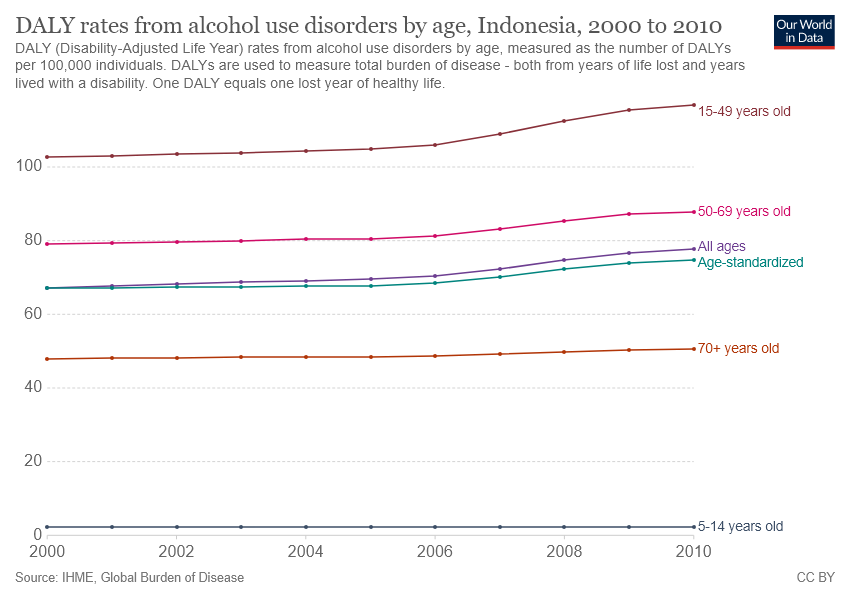Highlight a few significant elements in this photo. The pink color line represents the age group of 50-69 years old. In 2010, alcohol use disorders recorded the highest DALY rates among individuals aged 15-49 years old in Indonesia. 